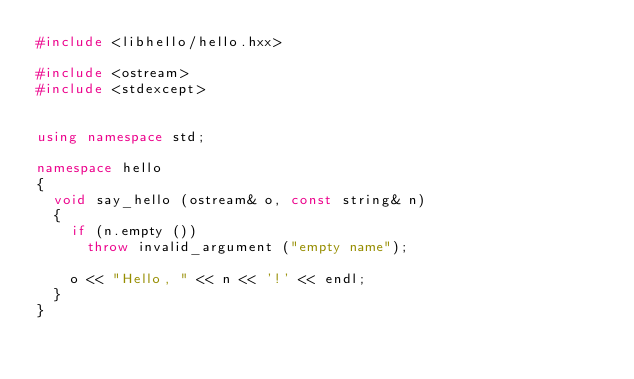Convert code to text. <code><loc_0><loc_0><loc_500><loc_500><_C++_>#include <libhello/hello.hxx>

#include <ostream>
#include <stdexcept>


using namespace std;

namespace hello
{
  void say_hello (ostream& o, const string& n)
  {
    if (n.empty ())
      throw invalid_argument ("empty name");

    o << "Hello, " << n << '!' << endl;
  }
}
</code> 